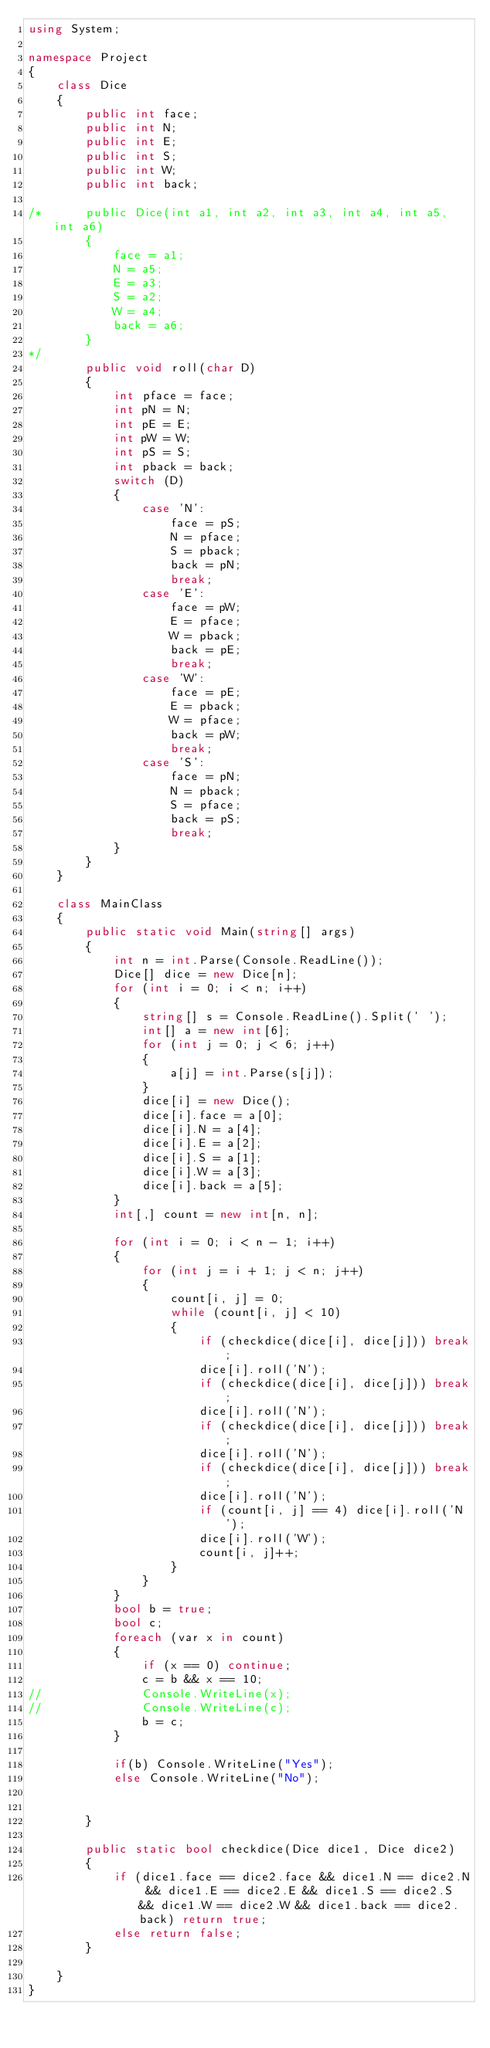<code> <loc_0><loc_0><loc_500><loc_500><_C#_>using System;

namespace Project
{
	class Dice
	{
		public int face;
		public int N;
		public int E;
		public int S;
		public int W;
		public int back;

/*		public Dice(int a1, int a2, int a3, int a4, int a5, int a6)
		{
			face = a1;
			N = a5;
			E = a3;
			S = a2;
			W = a4;
			back = a6;
		}
*/		
		public void roll(char D)
		{
			int pface = face;
			int pN = N;
			int pE = E;
			int pW = W;
			int pS = S;
			int pback = back;
			switch (D)
			{
				case 'N':
					face = pS;
					N = pface;
					S = pback;
					back = pN;
					break;
				case 'E':
					face = pW;
					E = pface;
					W = pback;
					back = pE;
					break;
				case 'W':
					face = pE;
					E = pback;
					W = pface;
					back = pW;
					break;
				case 'S':
					face = pN;
					N = pback;
					S = pface;
					back = pS;
					break;
			}
		}
	}

	class MainClass
	{
		public static void Main(string[] args)
		{
			int n = int.Parse(Console.ReadLine());
			Dice[] dice = new Dice[n];
			for (int i = 0; i < n; i++)
			{
				string[] s = Console.ReadLine().Split(' ');
				int[] a = new int[6];
				for (int j = 0; j < 6; j++)
				{
					a[j] = int.Parse(s[j]);
				}
				dice[i] = new Dice();
				dice[i].face = a[0];
				dice[i].N = a[4];
				dice[i].E = a[2];
				dice[i].S = a[1];
				dice[i].W = a[3];
				dice[i].back = a[5];
			}
			int[,] count = new int[n, n];

			for (int i = 0; i < n - 1; i++)
			{
				for (int j = i + 1; j < n; j++)
				{
					count[i, j] = 0;
					while (count[i, j] < 10)
					{
						if (checkdice(dice[i], dice[j])) break;
						dice[i].roll('N');
						if (checkdice(dice[i], dice[j])) break;
						dice[i].roll('N');
						if (checkdice(dice[i], dice[j])) break;
						dice[i].roll('N');
						if (checkdice(dice[i], dice[j])) break;
						dice[i].roll('N');
						if (count[i, j] == 4) dice[i].roll('N');
						dice[i].roll('W');
						count[i, j]++;
					}
				}
			}
			bool b = true;
			bool c;
			foreach (var x in count)
			{
				if (x == 0) continue;
				c = b && x == 10;
//				Console.WriteLine(x);
//				Console.WriteLine(c);
				b = c;
			}

			if(b) Console.WriteLine("Yes");
			else Console.WriteLine("No");


		}

		public static bool checkdice(Dice dice1, Dice dice2)
		{
			if (dice1.face == dice2.face && dice1.N == dice2.N && dice1.E == dice2.E && dice1.S == dice2.S && dice1.W == dice2.W && dice1.back == dice2.back) return true;
			else return false;
		}

	}
}</code> 